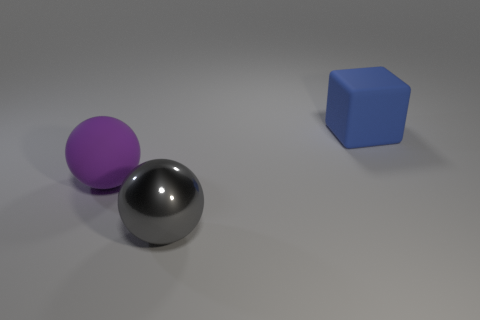The large thing that is behind the big shiny object and to the right of the purple matte sphere is what color?
Ensure brevity in your answer.  Blue. How many cubes are large blue objects or big gray rubber things?
Make the answer very short. 1. Are there fewer big blue matte things left of the large blue object than big brown cylinders?
Ensure brevity in your answer.  No. The other thing that is made of the same material as the purple object is what shape?
Offer a very short reply. Cube. How many things are blue shiny spheres or balls?
Give a very brief answer. 2. What is the big sphere right of the big rubber thing on the left side of the gray ball made of?
Make the answer very short. Metal. Are there any large cyan cylinders that have the same material as the large purple ball?
Your answer should be very brief. No. What is the shape of the big matte object in front of the matte thing on the right side of the big sphere in front of the large matte ball?
Your answer should be very brief. Sphere. What material is the big gray sphere?
Keep it short and to the point. Metal. The big thing that is made of the same material as the big blue cube is what color?
Provide a succinct answer. Purple. 